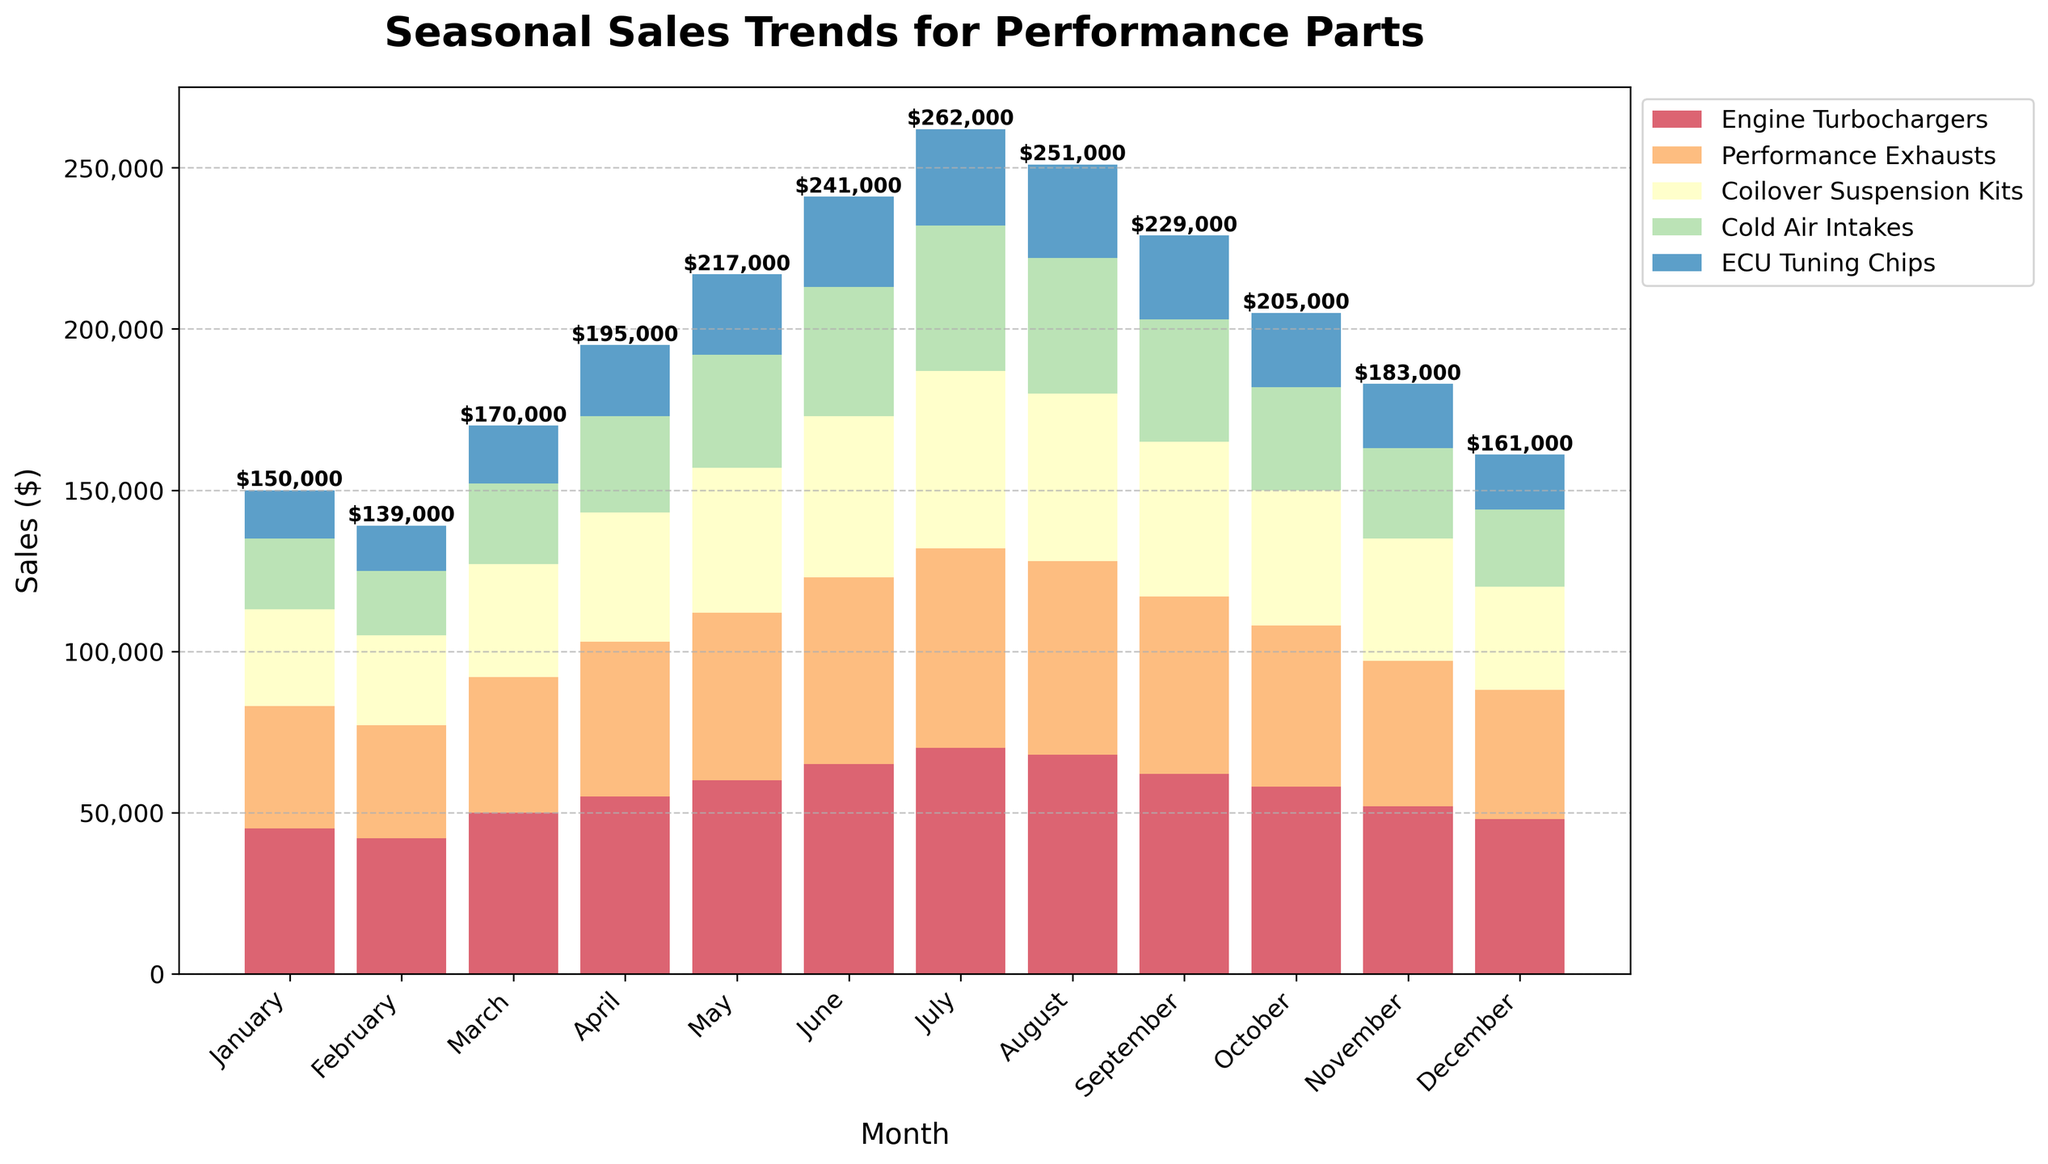Which month has the highest total sales? To determine the month with the highest total sales, we need to compare the total sales of all the months. By observing the heights of the bars, we see that July has the highest stack, indicating the highest total sales.
Answer: July Which product category had the highest sales in June? To find the product category with the highest sales in June, we need to compare the heights of the individual bars for June. The tallest bar segment in June is for Engine Turbochargers.
Answer: Engine Turbochargers How do the sales of ECU Tuning Chips in April compare to those in December? To compare the sales of ECU Tuning Chips in April and December, observe the height of the bar segments for ECU Tuning Chips in these two months. In April, the sales are significantly higher compared to December.
Answer: April's sales are higher What is the difference in total sales between May and February? Calculate the total sales for May by summing the sales of all categories: (60000 + 52000 + 45000 + 35000 + 25000) = 217000. Repeat for February: (42000 + 35000 + 28000 + 20000 + 14000) = 139000. The difference is 217000 - 139000 = 78000.
Answer: 78000 Which month has the lowest sales for Cold Air Intakes? Compare the heights of the Cold Air Intakes segments for each month. December has the shortest segment, indicating the lowest sales.
Answer: December How do the sales trends for Engine Turbochargers compare to Performance Exhausts over the year? By observing the height of the bar segments for Engine Turbochargers and Performance Exhausts across all months, we see that both categories show increasing sales trends until July, then a decrease towards December.
Answer: Similar increasing then decreasing trend Calculate the average monthly sales for Performance Exhausts. Sum the monthly sales of Performance Exhausts: (38000 + 35000 + 42000 + 48000 + 52000 + 58000 + 62000 + 60000 + 55000 + 50000 + 45000 + 40000) = 625000. Then divide by 12 (months): 625000 / 12 ≈ 52083.33.
Answer: ≈ 52083.33 What is the combined total sales for all categories in July and August? Compute the total sales for July: (70000 + 62000 + 55000 + 45000 + 30000) = 262000. For August: (68000 + 60000 + 52000 + 42000 + 29000) = 251000. Combined, it is 262000 + 251000 = 513000.
Answer: 513000 